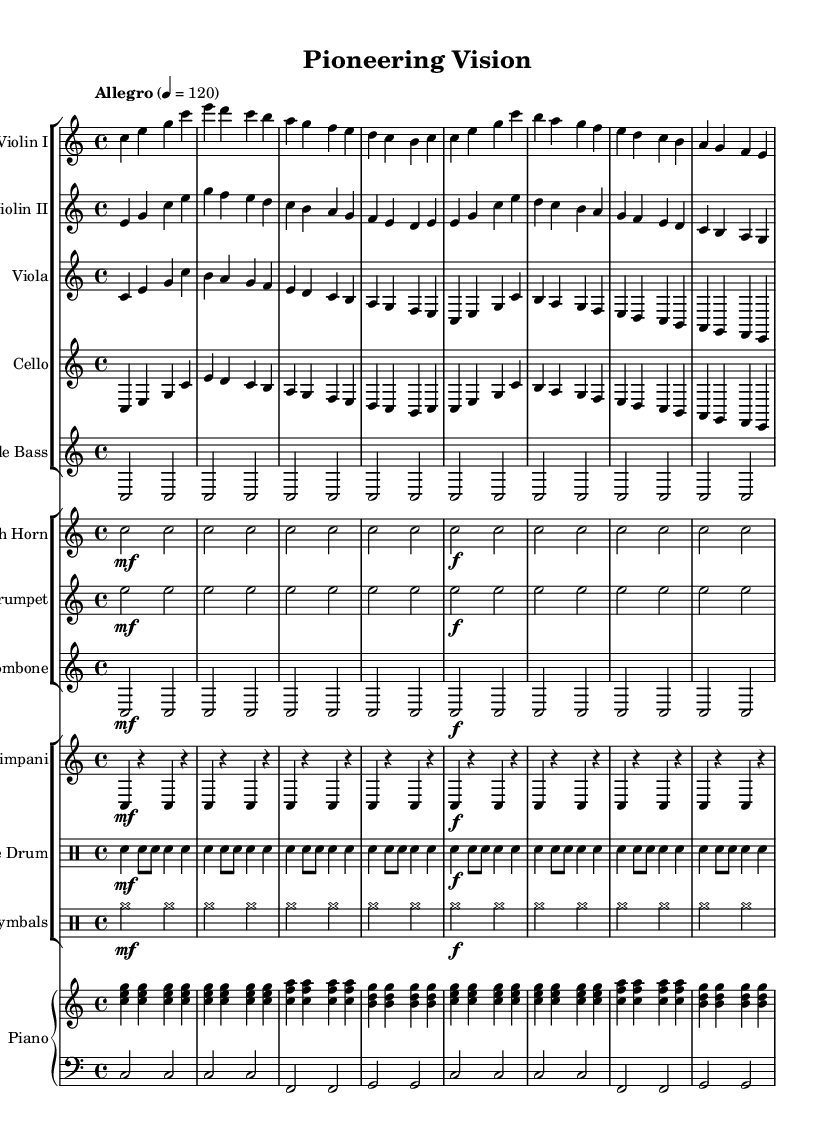What is the key signature of this music? The key signature is indicated by the absence of sharps or flats at the beginning of the staff. This shows that the piece is in C major.
Answer: C major What is the time signature of this music? The time signature is displayed as "4/4" at the beginning of the score, indicating four beats per measure with a quarter note receiving one beat.
Answer: 4/4 What is the tempo marking of this piece? The tempo marking is "Allegro" with a metronome marking of 120, which suggests a fast and lively pace.
Answer: Allegro, 120 How many measures are included in the introduction section? By counting the measures before the theme starts, we can see there are eight measures in the introduction.
Answer: 8 Which instruments are featured in the orchestral composition? The score lists a variety of instruments including Violins, Viola, Cello, Double Bass, Horn, Trumpet, Trombone, Timpani, Snare Drum, Cymbals, and Piano.
Answer: 11 instruments Is there a variation in dynamics throughout the piece? Yes, the dynamic markings indicate variations, with sections marked as "mf" (mezzo forte) and "f" (forte) showing changes in volume.
Answer: Yes What is the structure of the music based on the provided data? The structure primarily consists of an introduction followed by Theme A, suggesting a classical form often used in orchestral compositions.
Answer: Introduction and Theme A 